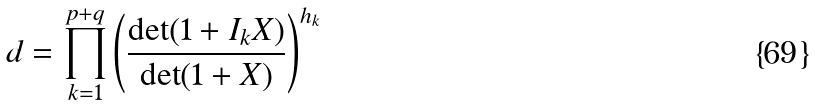Convert formula to latex. <formula><loc_0><loc_0><loc_500><loc_500>d = \prod _ { k = 1 } ^ { p + q } \left ( \frac { \det ( 1 + I _ { k } X ) } { \det ( 1 + X ) } \right ) ^ { h _ { k } }</formula> 